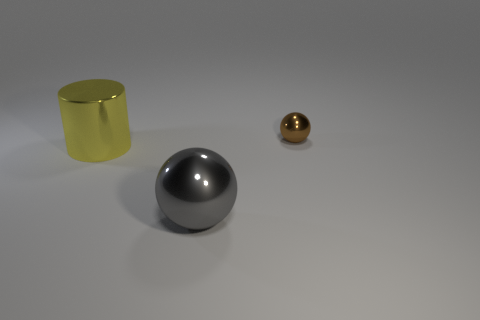Add 1 small red shiny cubes. How many objects exist? 4 Subtract all cylinders. How many objects are left? 2 Subtract 1 gray balls. How many objects are left? 2 Subtract all large red metal objects. Subtract all metallic balls. How many objects are left? 1 Add 2 yellow cylinders. How many yellow cylinders are left? 3 Add 2 brown rubber cylinders. How many brown rubber cylinders exist? 2 